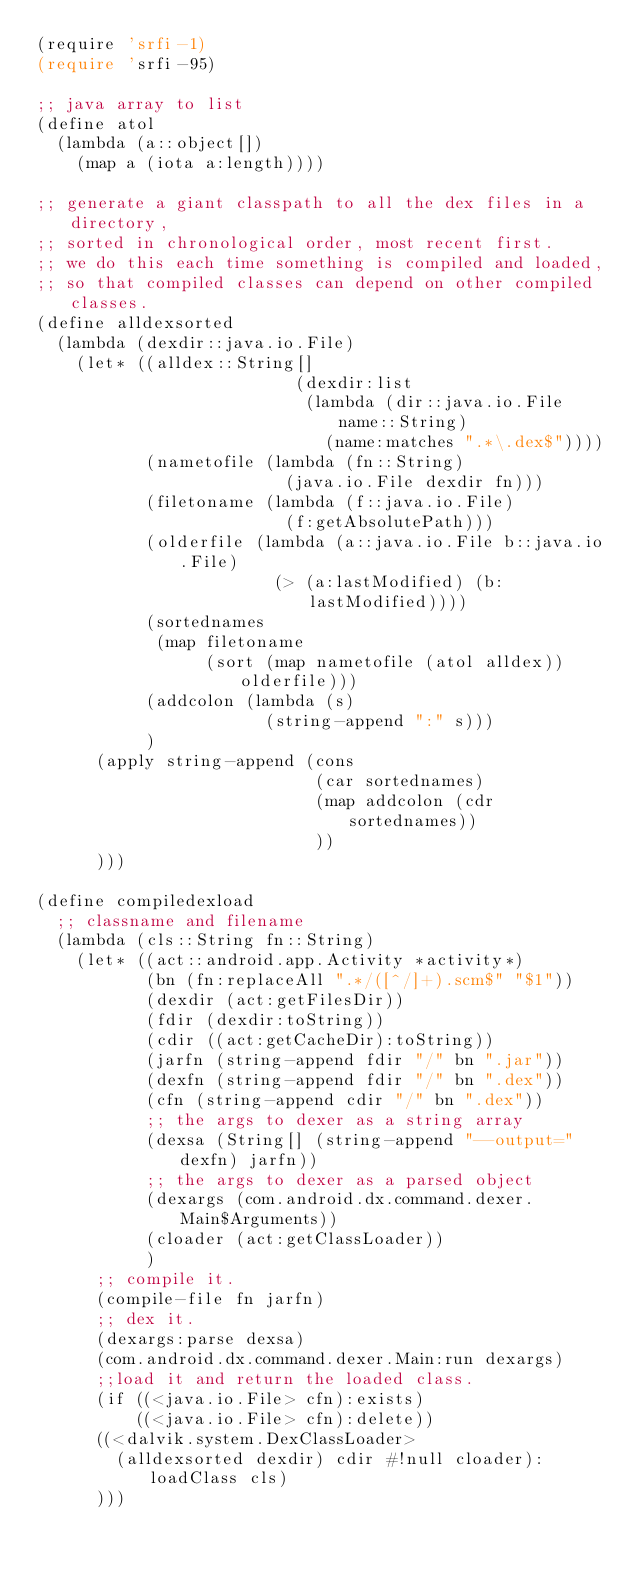<code> <loc_0><loc_0><loc_500><loc_500><_Scheme_>(require 'srfi-1)
(require 'srfi-95)

;; java array to list
(define atol
  (lambda (a::object[])
    (map a (iota a:length))))

;; generate a giant classpath to all the dex files in a directory, 
;; sorted in chronological order, most recent first.
;; we do this each time something is compiled and loaded, 
;; so that compiled classes can depend on other compiled classes.
(define alldexsorted
  (lambda (dexdir::java.io.File)
    (let* ((alldex::String[] 
                          (dexdir:list 
                           (lambda (dir::java.io.File name::String) 
                             (name:matches ".*\.dex$"))))
           (nametofile (lambda (fn::String)
                         (java.io.File dexdir fn)))
           (filetoname (lambda (f::java.io.File)
                         (f:getAbsolutePath)))
           (olderfile (lambda (a::java.io.File b::java.io.File)
                        (> (a:lastModified) (b:lastModified))))
           (sortednames
            (map filetoname 
                 (sort (map nametofile (atol alldex)) olderfile)))
           (addcolon (lambda (s)
                       (string-append ":" s)))
           )
      (apply string-append (cons 
                            (car sortednames) 
                            (map addcolon (cdr sortednames))
                            ))
      )))

(define compiledexload
  ;; classname and filename 
  (lambda (cls::String fn::String)
    (let* ((act::android.app.Activity *activity*)
           (bn (fn:replaceAll ".*/([^/]+).scm$" "$1"))
           (dexdir (act:getFilesDir))
           (fdir (dexdir:toString))
           (cdir ((act:getCacheDir):toString))
           (jarfn (string-append fdir "/" bn ".jar"))
           (dexfn (string-append fdir "/" bn ".dex"))
           (cfn (string-append cdir "/" bn ".dex"))
           ;; the args to dexer as a string array
           (dexsa (String[] (string-append "--output=" dexfn) jarfn))
           ;; the args to dexer as a parsed object
           (dexargs (com.android.dx.command.dexer.Main$Arguments))
           (cloader (act:getClassLoader))
           )
      ;; compile it.
      (compile-file fn jarfn)
      ;; dex it.
      (dexargs:parse dexsa)
      (com.android.dx.command.dexer.Main:run dexargs)
      ;;load it and return the loaded class.
      (if ((<java.io.File> cfn):exists)
          ((<java.io.File> cfn):delete))
      ((<dalvik.system.DexClassLoader> 
        (alldexsorted dexdir) cdir #!null cloader):loadClass cls)
      )))
</code> 